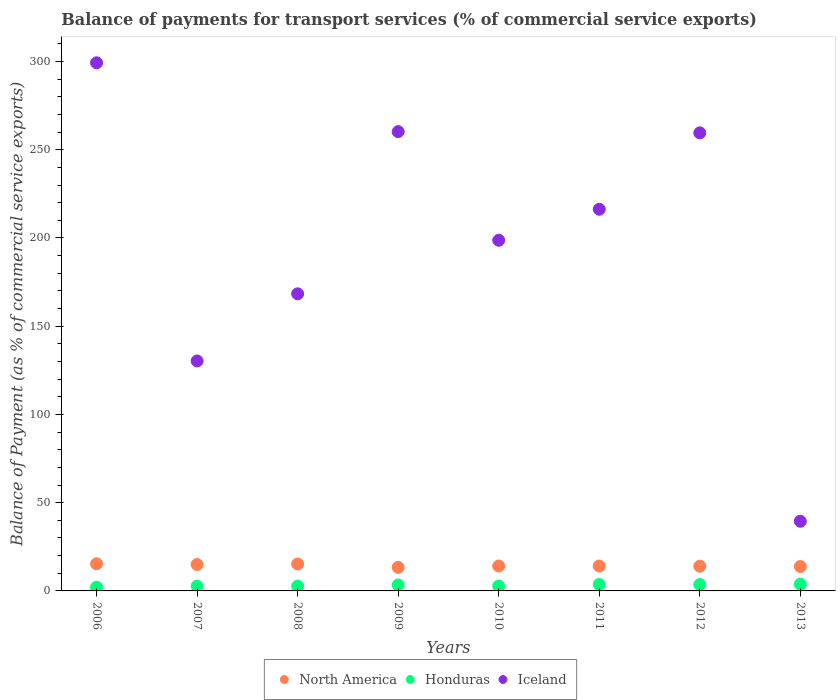What is the balance of payments for transport services in Honduras in 2010?
Offer a very short reply. 2.8. Across all years, what is the maximum balance of payments for transport services in Iceland?
Give a very brief answer. 299.28. Across all years, what is the minimum balance of payments for transport services in North America?
Give a very brief answer. 13.36. In which year was the balance of payments for transport services in North America maximum?
Offer a very short reply. 2006. In which year was the balance of payments for transport services in Iceland minimum?
Provide a succinct answer. 2013. What is the total balance of payments for transport services in Iceland in the graph?
Offer a terse response. 1572.26. What is the difference between the balance of payments for transport services in Honduras in 2010 and that in 2013?
Offer a very short reply. -1. What is the difference between the balance of payments for transport services in Honduras in 2011 and the balance of payments for transport services in North America in 2010?
Your answer should be very brief. -10.45. What is the average balance of payments for transport services in Honduras per year?
Your answer should be compact. 3.11. In the year 2011, what is the difference between the balance of payments for transport services in North America and balance of payments for transport services in Honduras?
Provide a succinct answer. 10.44. What is the ratio of the balance of payments for transport services in Honduras in 2010 to that in 2011?
Give a very brief answer. 0.77. What is the difference between the highest and the second highest balance of payments for transport services in North America?
Keep it short and to the point. 0.12. What is the difference between the highest and the lowest balance of payments for transport services in Iceland?
Offer a terse response. 259.8. Is the sum of the balance of payments for transport services in Iceland in 2006 and 2008 greater than the maximum balance of payments for transport services in Honduras across all years?
Offer a very short reply. Yes. Is it the case that in every year, the sum of the balance of payments for transport services in Iceland and balance of payments for transport services in North America  is greater than the balance of payments for transport services in Honduras?
Make the answer very short. Yes. Does the balance of payments for transport services in Honduras monotonically increase over the years?
Give a very brief answer. No. Is the balance of payments for transport services in Honduras strictly less than the balance of payments for transport services in North America over the years?
Ensure brevity in your answer.  Yes. How many dotlines are there?
Provide a short and direct response. 3. Are the values on the major ticks of Y-axis written in scientific E-notation?
Keep it short and to the point. No. Where does the legend appear in the graph?
Keep it short and to the point. Bottom center. What is the title of the graph?
Ensure brevity in your answer.  Balance of payments for transport services (% of commercial service exports). What is the label or title of the X-axis?
Ensure brevity in your answer.  Years. What is the label or title of the Y-axis?
Give a very brief answer. Balance of Payment (as % of commercial service exports). What is the Balance of Payment (as % of commercial service exports) in North America in 2006?
Keep it short and to the point. 15.37. What is the Balance of Payment (as % of commercial service exports) of Honduras in 2006?
Your response must be concise. 2.14. What is the Balance of Payment (as % of commercial service exports) in Iceland in 2006?
Your answer should be very brief. 299.28. What is the Balance of Payment (as % of commercial service exports) of North America in 2007?
Your answer should be compact. 14.97. What is the Balance of Payment (as % of commercial service exports) in Honduras in 2007?
Ensure brevity in your answer.  2.73. What is the Balance of Payment (as % of commercial service exports) in Iceland in 2007?
Your answer should be compact. 130.32. What is the Balance of Payment (as % of commercial service exports) of North America in 2008?
Ensure brevity in your answer.  15.25. What is the Balance of Payment (as % of commercial service exports) in Honduras in 2008?
Offer a very short reply. 2.75. What is the Balance of Payment (as % of commercial service exports) in Iceland in 2008?
Your answer should be very brief. 168.36. What is the Balance of Payment (as % of commercial service exports) in North America in 2009?
Ensure brevity in your answer.  13.36. What is the Balance of Payment (as % of commercial service exports) of Honduras in 2009?
Give a very brief answer. 3.39. What is the Balance of Payment (as % of commercial service exports) of Iceland in 2009?
Give a very brief answer. 260.27. What is the Balance of Payment (as % of commercial service exports) of North America in 2010?
Your answer should be very brief. 14.12. What is the Balance of Payment (as % of commercial service exports) of Honduras in 2010?
Keep it short and to the point. 2.8. What is the Balance of Payment (as % of commercial service exports) of Iceland in 2010?
Offer a very short reply. 198.71. What is the Balance of Payment (as % of commercial service exports) of North America in 2011?
Provide a succinct answer. 14.11. What is the Balance of Payment (as % of commercial service exports) in Honduras in 2011?
Make the answer very short. 3.66. What is the Balance of Payment (as % of commercial service exports) in Iceland in 2011?
Your answer should be very brief. 216.28. What is the Balance of Payment (as % of commercial service exports) of North America in 2012?
Keep it short and to the point. 13.99. What is the Balance of Payment (as % of commercial service exports) of Honduras in 2012?
Offer a terse response. 3.61. What is the Balance of Payment (as % of commercial service exports) of Iceland in 2012?
Provide a succinct answer. 259.57. What is the Balance of Payment (as % of commercial service exports) in North America in 2013?
Your response must be concise. 13.84. What is the Balance of Payment (as % of commercial service exports) in Honduras in 2013?
Keep it short and to the point. 3.8. What is the Balance of Payment (as % of commercial service exports) in Iceland in 2013?
Make the answer very short. 39.47. Across all years, what is the maximum Balance of Payment (as % of commercial service exports) in North America?
Give a very brief answer. 15.37. Across all years, what is the maximum Balance of Payment (as % of commercial service exports) of Honduras?
Provide a succinct answer. 3.8. Across all years, what is the maximum Balance of Payment (as % of commercial service exports) of Iceland?
Provide a succinct answer. 299.28. Across all years, what is the minimum Balance of Payment (as % of commercial service exports) of North America?
Ensure brevity in your answer.  13.36. Across all years, what is the minimum Balance of Payment (as % of commercial service exports) of Honduras?
Your answer should be compact. 2.14. Across all years, what is the minimum Balance of Payment (as % of commercial service exports) of Iceland?
Give a very brief answer. 39.47. What is the total Balance of Payment (as % of commercial service exports) of North America in the graph?
Offer a very short reply. 115.01. What is the total Balance of Payment (as % of commercial service exports) of Honduras in the graph?
Offer a very short reply. 24.88. What is the total Balance of Payment (as % of commercial service exports) in Iceland in the graph?
Your answer should be compact. 1572.26. What is the difference between the Balance of Payment (as % of commercial service exports) in North America in 2006 and that in 2007?
Provide a succinct answer. 0.4. What is the difference between the Balance of Payment (as % of commercial service exports) of Honduras in 2006 and that in 2007?
Ensure brevity in your answer.  -0.6. What is the difference between the Balance of Payment (as % of commercial service exports) of Iceland in 2006 and that in 2007?
Provide a short and direct response. 168.95. What is the difference between the Balance of Payment (as % of commercial service exports) in North America in 2006 and that in 2008?
Ensure brevity in your answer.  0.12. What is the difference between the Balance of Payment (as % of commercial service exports) in Honduras in 2006 and that in 2008?
Provide a succinct answer. -0.61. What is the difference between the Balance of Payment (as % of commercial service exports) of Iceland in 2006 and that in 2008?
Your answer should be very brief. 130.92. What is the difference between the Balance of Payment (as % of commercial service exports) of North America in 2006 and that in 2009?
Your response must be concise. 2.01. What is the difference between the Balance of Payment (as % of commercial service exports) of Honduras in 2006 and that in 2009?
Offer a terse response. -1.25. What is the difference between the Balance of Payment (as % of commercial service exports) in Iceland in 2006 and that in 2009?
Make the answer very short. 39.01. What is the difference between the Balance of Payment (as % of commercial service exports) of North America in 2006 and that in 2010?
Keep it short and to the point. 1.26. What is the difference between the Balance of Payment (as % of commercial service exports) in Honduras in 2006 and that in 2010?
Your answer should be very brief. -0.67. What is the difference between the Balance of Payment (as % of commercial service exports) of Iceland in 2006 and that in 2010?
Your answer should be compact. 100.57. What is the difference between the Balance of Payment (as % of commercial service exports) in North America in 2006 and that in 2011?
Your response must be concise. 1.27. What is the difference between the Balance of Payment (as % of commercial service exports) in Honduras in 2006 and that in 2011?
Offer a terse response. -1.53. What is the difference between the Balance of Payment (as % of commercial service exports) in Iceland in 2006 and that in 2011?
Give a very brief answer. 83. What is the difference between the Balance of Payment (as % of commercial service exports) of North America in 2006 and that in 2012?
Offer a terse response. 1.38. What is the difference between the Balance of Payment (as % of commercial service exports) in Honduras in 2006 and that in 2012?
Your answer should be compact. -1.47. What is the difference between the Balance of Payment (as % of commercial service exports) in Iceland in 2006 and that in 2012?
Offer a terse response. 39.71. What is the difference between the Balance of Payment (as % of commercial service exports) in North America in 2006 and that in 2013?
Your response must be concise. 1.53. What is the difference between the Balance of Payment (as % of commercial service exports) in Honduras in 2006 and that in 2013?
Make the answer very short. -1.67. What is the difference between the Balance of Payment (as % of commercial service exports) in Iceland in 2006 and that in 2013?
Make the answer very short. 259.8. What is the difference between the Balance of Payment (as % of commercial service exports) of North America in 2007 and that in 2008?
Provide a short and direct response. -0.28. What is the difference between the Balance of Payment (as % of commercial service exports) in Honduras in 2007 and that in 2008?
Ensure brevity in your answer.  -0.02. What is the difference between the Balance of Payment (as % of commercial service exports) in Iceland in 2007 and that in 2008?
Your answer should be very brief. -38.04. What is the difference between the Balance of Payment (as % of commercial service exports) in North America in 2007 and that in 2009?
Ensure brevity in your answer.  1.62. What is the difference between the Balance of Payment (as % of commercial service exports) of Honduras in 2007 and that in 2009?
Your response must be concise. -0.66. What is the difference between the Balance of Payment (as % of commercial service exports) of Iceland in 2007 and that in 2009?
Your response must be concise. -129.95. What is the difference between the Balance of Payment (as % of commercial service exports) of North America in 2007 and that in 2010?
Your answer should be very brief. 0.86. What is the difference between the Balance of Payment (as % of commercial service exports) in Honduras in 2007 and that in 2010?
Make the answer very short. -0.07. What is the difference between the Balance of Payment (as % of commercial service exports) in Iceland in 2007 and that in 2010?
Give a very brief answer. -68.38. What is the difference between the Balance of Payment (as % of commercial service exports) of North America in 2007 and that in 2011?
Provide a short and direct response. 0.87. What is the difference between the Balance of Payment (as % of commercial service exports) of Honduras in 2007 and that in 2011?
Offer a terse response. -0.93. What is the difference between the Balance of Payment (as % of commercial service exports) of Iceland in 2007 and that in 2011?
Give a very brief answer. -85.96. What is the difference between the Balance of Payment (as % of commercial service exports) of North America in 2007 and that in 2012?
Keep it short and to the point. 0.98. What is the difference between the Balance of Payment (as % of commercial service exports) in Honduras in 2007 and that in 2012?
Provide a succinct answer. -0.88. What is the difference between the Balance of Payment (as % of commercial service exports) of Iceland in 2007 and that in 2012?
Keep it short and to the point. -129.25. What is the difference between the Balance of Payment (as % of commercial service exports) in North America in 2007 and that in 2013?
Ensure brevity in your answer.  1.13. What is the difference between the Balance of Payment (as % of commercial service exports) in Honduras in 2007 and that in 2013?
Your answer should be very brief. -1.07. What is the difference between the Balance of Payment (as % of commercial service exports) of Iceland in 2007 and that in 2013?
Your answer should be compact. 90.85. What is the difference between the Balance of Payment (as % of commercial service exports) in North America in 2008 and that in 2009?
Provide a succinct answer. 1.89. What is the difference between the Balance of Payment (as % of commercial service exports) of Honduras in 2008 and that in 2009?
Provide a short and direct response. -0.64. What is the difference between the Balance of Payment (as % of commercial service exports) of Iceland in 2008 and that in 2009?
Give a very brief answer. -91.91. What is the difference between the Balance of Payment (as % of commercial service exports) in North America in 2008 and that in 2010?
Your response must be concise. 1.14. What is the difference between the Balance of Payment (as % of commercial service exports) in Honduras in 2008 and that in 2010?
Provide a succinct answer. -0.05. What is the difference between the Balance of Payment (as % of commercial service exports) in Iceland in 2008 and that in 2010?
Your answer should be compact. -30.35. What is the difference between the Balance of Payment (as % of commercial service exports) of North America in 2008 and that in 2011?
Your answer should be very brief. 1.15. What is the difference between the Balance of Payment (as % of commercial service exports) of Honduras in 2008 and that in 2011?
Offer a terse response. -0.91. What is the difference between the Balance of Payment (as % of commercial service exports) of Iceland in 2008 and that in 2011?
Your answer should be compact. -47.92. What is the difference between the Balance of Payment (as % of commercial service exports) of North America in 2008 and that in 2012?
Your response must be concise. 1.26. What is the difference between the Balance of Payment (as % of commercial service exports) of Honduras in 2008 and that in 2012?
Your answer should be very brief. -0.86. What is the difference between the Balance of Payment (as % of commercial service exports) in Iceland in 2008 and that in 2012?
Provide a short and direct response. -91.21. What is the difference between the Balance of Payment (as % of commercial service exports) in North America in 2008 and that in 2013?
Make the answer very short. 1.41. What is the difference between the Balance of Payment (as % of commercial service exports) of Honduras in 2008 and that in 2013?
Keep it short and to the point. -1.05. What is the difference between the Balance of Payment (as % of commercial service exports) of Iceland in 2008 and that in 2013?
Provide a short and direct response. 128.89. What is the difference between the Balance of Payment (as % of commercial service exports) in North America in 2009 and that in 2010?
Your response must be concise. -0.76. What is the difference between the Balance of Payment (as % of commercial service exports) in Honduras in 2009 and that in 2010?
Keep it short and to the point. 0.59. What is the difference between the Balance of Payment (as % of commercial service exports) in Iceland in 2009 and that in 2010?
Provide a succinct answer. 61.56. What is the difference between the Balance of Payment (as % of commercial service exports) of North America in 2009 and that in 2011?
Provide a succinct answer. -0.75. What is the difference between the Balance of Payment (as % of commercial service exports) of Honduras in 2009 and that in 2011?
Provide a succinct answer. -0.27. What is the difference between the Balance of Payment (as % of commercial service exports) in Iceland in 2009 and that in 2011?
Offer a very short reply. 43.99. What is the difference between the Balance of Payment (as % of commercial service exports) in North America in 2009 and that in 2012?
Offer a very short reply. -0.64. What is the difference between the Balance of Payment (as % of commercial service exports) of Honduras in 2009 and that in 2012?
Offer a very short reply. -0.22. What is the difference between the Balance of Payment (as % of commercial service exports) in Iceland in 2009 and that in 2012?
Ensure brevity in your answer.  0.7. What is the difference between the Balance of Payment (as % of commercial service exports) of North America in 2009 and that in 2013?
Your answer should be compact. -0.48. What is the difference between the Balance of Payment (as % of commercial service exports) in Honduras in 2009 and that in 2013?
Offer a terse response. -0.41. What is the difference between the Balance of Payment (as % of commercial service exports) of Iceland in 2009 and that in 2013?
Keep it short and to the point. 220.79. What is the difference between the Balance of Payment (as % of commercial service exports) of North America in 2010 and that in 2011?
Keep it short and to the point. 0.01. What is the difference between the Balance of Payment (as % of commercial service exports) of Honduras in 2010 and that in 2011?
Provide a succinct answer. -0.86. What is the difference between the Balance of Payment (as % of commercial service exports) in Iceland in 2010 and that in 2011?
Keep it short and to the point. -17.57. What is the difference between the Balance of Payment (as % of commercial service exports) in North America in 2010 and that in 2012?
Your answer should be compact. 0.12. What is the difference between the Balance of Payment (as % of commercial service exports) of Honduras in 2010 and that in 2012?
Keep it short and to the point. -0.81. What is the difference between the Balance of Payment (as % of commercial service exports) in Iceland in 2010 and that in 2012?
Your answer should be very brief. -60.86. What is the difference between the Balance of Payment (as % of commercial service exports) of North America in 2010 and that in 2013?
Provide a short and direct response. 0.27. What is the difference between the Balance of Payment (as % of commercial service exports) in Honduras in 2010 and that in 2013?
Your answer should be compact. -1. What is the difference between the Balance of Payment (as % of commercial service exports) in Iceland in 2010 and that in 2013?
Your answer should be compact. 159.23. What is the difference between the Balance of Payment (as % of commercial service exports) of North America in 2011 and that in 2012?
Make the answer very short. 0.11. What is the difference between the Balance of Payment (as % of commercial service exports) of Honduras in 2011 and that in 2012?
Offer a very short reply. 0.05. What is the difference between the Balance of Payment (as % of commercial service exports) in Iceland in 2011 and that in 2012?
Offer a terse response. -43.29. What is the difference between the Balance of Payment (as % of commercial service exports) in North America in 2011 and that in 2013?
Ensure brevity in your answer.  0.26. What is the difference between the Balance of Payment (as % of commercial service exports) of Honduras in 2011 and that in 2013?
Give a very brief answer. -0.14. What is the difference between the Balance of Payment (as % of commercial service exports) in Iceland in 2011 and that in 2013?
Offer a very short reply. 176.81. What is the difference between the Balance of Payment (as % of commercial service exports) in North America in 2012 and that in 2013?
Ensure brevity in your answer.  0.15. What is the difference between the Balance of Payment (as % of commercial service exports) of Honduras in 2012 and that in 2013?
Your response must be concise. -0.19. What is the difference between the Balance of Payment (as % of commercial service exports) in Iceland in 2012 and that in 2013?
Provide a succinct answer. 220.1. What is the difference between the Balance of Payment (as % of commercial service exports) in North America in 2006 and the Balance of Payment (as % of commercial service exports) in Honduras in 2007?
Your answer should be very brief. 12.64. What is the difference between the Balance of Payment (as % of commercial service exports) in North America in 2006 and the Balance of Payment (as % of commercial service exports) in Iceland in 2007?
Give a very brief answer. -114.95. What is the difference between the Balance of Payment (as % of commercial service exports) of Honduras in 2006 and the Balance of Payment (as % of commercial service exports) of Iceland in 2007?
Offer a very short reply. -128.19. What is the difference between the Balance of Payment (as % of commercial service exports) of North America in 2006 and the Balance of Payment (as % of commercial service exports) of Honduras in 2008?
Offer a terse response. 12.62. What is the difference between the Balance of Payment (as % of commercial service exports) in North America in 2006 and the Balance of Payment (as % of commercial service exports) in Iceland in 2008?
Your response must be concise. -152.99. What is the difference between the Balance of Payment (as % of commercial service exports) in Honduras in 2006 and the Balance of Payment (as % of commercial service exports) in Iceland in 2008?
Your answer should be compact. -166.23. What is the difference between the Balance of Payment (as % of commercial service exports) of North America in 2006 and the Balance of Payment (as % of commercial service exports) of Honduras in 2009?
Provide a short and direct response. 11.98. What is the difference between the Balance of Payment (as % of commercial service exports) in North America in 2006 and the Balance of Payment (as % of commercial service exports) in Iceland in 2009?
Offer a very short reply. -244.9. What is the difference between the Balance of Payment (as % of commercial service exports) in Honduras in 2006 and the Balance of Payment (as % of commercial service exports) in Iceland in 2009?
Your response must be concise. -258.13. What is the difference between the Balance of Payment (as % of commercial service exports) in North America in 2006 and the Balance of Payment (as % of commercial service exports) in Honduras in 2010?
Make the answer very short. 12.57. What is the difference between the Balance of Payment (as % of commercial service exports) of North America in 2006 and the Balance of Payment (as % of commercial service exports) of Iceland in 2010?
Your answer should be very brief. -183.34. What is the difference between the Balance of Payment (as % of commercial service exports) in Honduras in 2006 and the Balance of Payment (as % of commercial service exports) in Iceland in 2010?
Offer a very short reply. -196.57. What is the difference between the Balance of Payment (as % of commercial service exports) of North America in 2006 and the Balance of Payment (as % of commercial service exports) of Honduras in 2011?
Offer a terse response. 11.71. What is the difference between the Balance of Payment (as % of commercial service exports) of North America in 2006 and the Balance of Payment (as % of commercial service exports) of Iceland in 2011?
Give a very brief answer. -200.91. What is the difference between the Balance of Payment (as % of commercial service exports) of Honduras in 2006 and the Balance of Payment (as % of commercial service exports) of Iceland in 2011?
Your response must be concise. -214.15. What is the difference between the Balance of Payment (as % of commercial service exports) of North America in 2006 and the Balance of Payment (as % of commercial service exports) of Honduras in 2012?
Provide a succinct answer. 11.76. What is the difference between the Balance of Payment (as % of commercial service exports) in North America in 2006 and the Balance of Payment (as % of commercial service exports) in Iceland in 2012?
Your answer should be compact. -244.2. What is the difference between the Balance of Payment (as % of commercial service exports) in Honduras in 2006 and the Balance of Payment (as % of commercial service exports) in Iceland in 2012?
Your response must be concise. -257.44. What is the difference between the Balance of Payment (as % of commercial service exports) of North America in 2006 and the Balance of Payment (as % of commercial service exports) of Honduras in 2013?
Your answer should be very brief. 11.57. What is the difference between the Balance of Payment (as % of commercial service exports) in North America in 2006 and the Balance of Payment (as % of commercial service exports) in Iceland in 2013?
Your answer should be compact. -24.1. What is the difference between the Balance of Payment (as % of commercial service exports) of Honduras in 2006 and the Balance of Payment (as % of commercial service exports) of Iceland in 2013?
Provide a succinct answer. -37.34. What is the difference between the Balance of Payment (as % of commercial service exports) of North America in 2007 and the Balance of Payment (as % of commercial service exports) of Honduras in 2008?
Your answer should be very brief. 12.22. What is the difference between the Balance of Payment (as % of commercial service exports) of North America in 2007 and the Balance of Payment (as % of commercial service exports) of Iceland in 2008?
Provide a short and direct response. -153.39. What is the difference between the Balance of Payment (as % of commercial service exports) in Honduras in 2007 and the Balance of Payment (as % of commercial service exports) in Iceland in 2008?
Ensure brevity in your answer.  -165.63. What is the difference between the Balance of Payment (as % of commercial service exports) in North America in 2007 and the Balance of Payment (as % of commercial service exports) in Honduras in 2009?
Offer a very short reply. 11.58. What is the difference between the Balance of Payment (as % of commercial service exports) of North America in 2007 and the Balance of Payment (as % of commercial service exports) of Iceland in 2009?
Keep it short and to the point. -245.29. What is the difference between the Balance of Payment (as % of commercial service exports) of Honduras in 2007 and the Balance of Payment (as % of commercial service exports) of Iceland in 2009?
Ensure brevity in your answer.  -257.54. What is the difference between the Balance of Payment (as % of commercial service exports) in North America in 2007 and the Balance of Payment (as % of commercial service exports) in Honduras in 2010?
Your response must be concise. 12.17. What is the difference between the Balance of Payment (as % of commercial service exports) in North America in 2007 and the Balance of Payment (as % of commercial service exports) in Iceland in 2010?
Provide a short and direct response. -183.73. What is the difference between the Balance of Payment (as % of commercial service exports) of Honduras in 2007 and the Balance of Payment (as % of commercial service exports) of Iceland in 2010?
Offer a terse response. -195.98. What is the difference between the Balance of Payment (as % of commercial service exports) in North America in 2007 and the Balance of Payment (as % of commercial service exports) in Honduras in 2011?
Provide a short and direct response. 11.31. What is the difference between the Balance of Payment (as % of commercial service exports) in North America in 2007 and the Balance of Payment (as % of commercial service exports) in Iceland in 2011?
Your answer should be compact. -201.31. What is the difference between the Balance of Payment (as % of commercial service exports) in Honduras in 2007 and the Balance of Payment (as % of commercial service exports) in Iceland in 2011?
Give a very brief answer. -213.55. What is the difference between the Balance of Payment (as % of commercial service exports) in North America in 2007 and the Balance of Payment (as % of commercial service exports) in Honduras in 2012?
Your answer should be compact. 11.37. What is the difference between the Balance of Payment (as % of commercial service exports) in North America in 2007 and the Balance of Payment (as % of commercial service exports) in Iceland in 2012?
Offer a very short reply. -244.6. What is the difference between the Balance of Payment (as % of commercial service exports) of Honduras in 2007 and the Balance of Payment (as % of commercial service exports) of Iceland in 2012?
Provide a succinct answer. -256.84. What is the difference between the Balance of Payment (as % of commercial service exports) of North America in 2007 and the Balance of Payment (as % of commercial service exports) of Honduras in 2013?
Your answer should be compact. 11.17. What is the difference between the Balance of Payment (as % of commercial service exports) of North America in 2007 and the Balance of Payment (as % of commercial service exports) of Iceland in 2013?
Your answer should be compact. -24.5. What is the difference between the Balance of Payment (as % of commercial service exports) in Honduras in 2007 and the Balance of Payment (as % of commercial service exports) in Iceland in 2013?
Keep it short and to the point. -36.74. What is the difference between the Balance of Payment (as % of commercial service exports) in North America in 2008 and the Balance of Payment (as % of commercial service exports) in Honduras in 2009?
Your response must be concise. 11.86. What is the difference between the Balance of Payment (as % of commercial service exports) of North America in 2008 and the Balance of Payment (as % of commercial service exports) of Iceland in 2009?
Provide a succinct answer. -245.02. What is the difference between the Balance of Payment (as % of commercial service exports) in Honduras in 2008 and the Balance of Payment (as % of commercial service exports) in Iceland in 2009?
Provide a succinct answer. -257.52. What is the difference between the Balance of Payment (as % of commercial service exports) of North America in 2008 and the Balance of Payment (as % of commercial service exports) of Honduras in 2010?
Offer a terse response. 12.45. What is the difference between the Balance of Payment (as % of commercial service exports) of North America in 2008 and the Balance of Payment (as % of commercial service exports) of Iceland in 2010?
Provide a succinct answer. -183.46. What is the difference between the Balance of Payment (as % of commercial service exports) of Honduras in 2008 and the Balance of Payment (as % of commercial service exports) of Iceland in 2010?
Your answer should be compact. -195.96. What is the difference between the Balance of Payment (as % of commercial service exports) in North America in 2008 and the Balance of Payment (as % of commercial service exports) in Honduras in 2011?
Your answer should be very brief. 11.59. What is the difference between the Balance of Payment (as % of commercial service exports) of North America in 2008 and the Balance of Payment (as % of commercial service exports) of Iceland in 2011?
Offer a terse response. -201.03. What is the difference between the Balance of Payment (as % of commercial service exports) in Honduras in 2008 and the Balance of Payment (as % of commercial service exports) in Iceland in 2011?
Keep it short and to the point. -213.53. What is the difference between the Balance of Payment (as % of commercial service exports) in North America in 2008 and the Balance of Payment (as % of commercial service exports) in Honduras in 2012?
Your answer should be very brief. 11.64. What is the difference between the Balance of Payment (as % of commercial service exports) of North America in 2008 and the Balance of Payment (as % of commercial service exports) of Iceland in 2012?
Ensure brevity in your answer.  -244.32. What is the difference between the Balance of Payment (as % of commercial service exports) of Honduras in 2008 and the Balance of Payment (as % of commercial service exports) of Iceland in 2012?
Offer a terse response. -256.82. What is the difference between the Balance of Payment (as % of commercial service exports) of North America in 2008 and the Balance of Payment (as % of commercial service exports) of Honduras in 2013?
Make the answer very short. 11.45. What is the difference between the Balance of Payment (as % of commercial service exports) of North America in 2008 and the Balance of Payment (as % of commercial service exports) of Iceland in 2013?
Provide a short and direct response. -24.22. What is the difference between the Balance of Payment (as % of commercial service exports) of Honduras in 2008 and the Balance of Payment (as % of commercial service exports) of Iceland in 2013?
Ensure brevity in your answer.  -36.72. What is the difference between the Balance of Payment (as % of commercial service exports) of North America in 2009 and the Balance of Payment (as % of commercial service exports) of Honduras in 2010?
Offer a very short reply. 10.56. What is the difference between the Balance of Payment (as % of commercial service exports) of North America in 2009 and the Balance of Payment (as % of commercial service exports) of Iceland in 2010?
Keep it short and to the point. -185.35. What is the difference between the Balance of Payment (as % of commercial service exports) of Honduras in 2009 and the Balance of Payment (as % of commercial service exports) of Iceland in 2010?
Offer a very short reply. -195.32. What is the difference between the Balance of Payment (as % of commercial service exports) of North America in 2009 and the Balance of Payment (as % of commercial service exports) of Honduras in 2011?
Make the answer very short. 9.7. What is the difference between the Balance of Payment (as % of commercial service exports) in North America in 2009 and the Balance of Payment (as % of commercial service exports) in Iceland in 2011?
Offer a very short reply. -202.92. What is the difference between the Balance of Payment (as % of commercial service exports) of Honduras in 2009 and the Balance of Payment (as % of commercial service exports) of Iceland in 2011?
Your answer should be compact. -212.89. What is the difference between the Balance of Payment (as % of commercial service exports) of North America in 2009 and the Balance of Payment (as % of commercial service exports) of Honduras in 2012?
Your response must be concise. 9.75. What is the difference between the Balance of Payment (as % of commercial service exports) of North America in 2009 and the Balance of Payment (as % of commercial service exports) of Iceland in 2012?
Ensure brevity in your answer.  -246.21. What is the difference between the Balance of Payment (as % of commercial service exports) in Honduras in 2009 and the Balance of Payment (as % of commercial service exports) in Iceland in 2012?
Provide a short and direct response. -256.18. What is the difference between the Balance of Payment (as % of commercial service exports) in North America in 2009 and the Balance of Payment (as % of commercial service exports) in Honduras in 2013?
Ensure brevity in your answer.  9.56. What is the difference between the Balance of Payment (as % of commercial service exports) in North America in 2009 and the Balance of Payment (as % of commercial service exports) in Iceland in 2013?
Keep it short and to the point. -26.12. What is the difference between the Balance of Payment (as % of commercial service exports) in Honduras in 2009 and the Balance of Payment (as % of commercial service exports) in Iceland in 2013?
Provide a succinct answer. -36.08. What is the difference between the Balance of Payment (as % of commercial service exports) in North America in 2010 and the Balance of Payment (as % of commercial service exports) in Honduras in 2011?
Give a very brief answer. 10.45. What is the difference between the Balance of Payment (as % of commercial service exports) of North America in 2010 and the Balance of Payment (as % of commercial service exports) of Iceland in 2011?
Offer a terse response. -202.17. What is the difference between the Balance of Payment (as % of commercial service exports) in Honduras in 2010 and the Balance of Payment (as % of commercial service exports) in Iceland in 2011?
Ensure brevity in your answer.  -213.48. What is the difference between the Balance of Payment (as % of commercial service exports) of North America in 2010 and the Balance of Payment (as % of commercial service exports) of Honduras in 2012?
Offer a very short reply. 10.51. What is the difference between the Balance of Payment (as % of commercial service exports) in North America in 2010 and the Balance of Payment (as % of commercial service exports) in Iceland in 2012?
Your answer should be compact. -245.46. What is the difference between the Balance of Payment (as % of commercial service exports) in Honduras in 2010 and the Balance of Payment (as % of commercial service exports) in Iceland in 2012?
Your response must be concise. -256.77. What is the difference between the Balance of Payment (as % of commercial service exports) in North America in 2010 and the Balance of Payment (as % of commercial service exports) in Honduras in 2013?
Provide a short and direct response. 10.31. What is the difference between the Balance of Payment (as % of commercial service exports) of North America in 2010 and the Balance of Payment (as % of commercial service exports) of Iceland in 2013?
Ensure brevity in your answer.  -25.36. What is the difference between the Balance of Payment (as % of commercial service exports) in Honduras in 2010 and the Balance of Payment (as % of commercial service exports) in Iceland in 2013?
Offer a very short reply. -36.67. What is the difference between the Balance of Payment (as % of commercial service exports) in North America in 2011 and the Balance of Payment (as % of commercial service exports) in Honduras in 2012?
Your answer should be compact. 10.5. What is the difference between the Balance of Payment (as % of commercial service exports) of North America in 2011 and the Balance of Payment (as % of commercial service exports) of Iceland in 2012?
Make the answer very short. -245.47. What is the difference between the Balance of Payment (as % of commercial service exports) of Honduras in 2011 and the Balance of Payment (as % of commercial service exports) of Iceland in 2012?
Your answer should be compact. -255.91. What is the difference between the Balance of Payment (as % of commercial service exports) of North America in 2011 and the Balance of Payment (as % of commercial service exports) of Honduras in 2013?
Provide a short and direct response. 10.3. What is the difference between the Balance of Payment (as % of commercial service exports) in North America in 2011 and the Balance of Payment (as % of commercial service exports) in Iceland in 2013?
Provide a short and direct response. -25.37. What is the difference between the Balance of Payment (as % of commercial service exports) in Honduras in 2011 and the Balance of Payment (as % of commercial service exports) in Iceland in 2013?
Give a very brief answer. -35.81. What is the difference between the Balance of Payment (as % of commercial service exports) in North America in 2012 and the Balance of Payment (as % of commercial service exports) in Honduras in 2013?
Make the answer very short. 10.19. What is the difference between the Balance of Payment (as % of commercial service exports) in North America in 2012 and the Balance of Payment (as % of commercial service exports) in Iceland in 2013?
Ensure brevity in your answer.  -25.48. What is the difference between the Balance of Payment (as % of commercial service exports) in Honduras in 2012 and the Balance of Payment (as % of commercial service exports) in Iceland in 2013?
Your answer should be compact. -35.87. What is the average Balance of Payment (as % of commercial service exports) of North America per year?
Give a very brief answer. 14.38. What is the average Balance of Payment (as % of commercial service exports) of Honduras per year?
Provide a succinct answer. 3.11. What is the average Balance of Payment (as % of commercial service exports) of Iceland per year?
Offer a very short reply. 196.53. In the year 2006, what is the difference between the Balance of Payment (as % of commercial service exports) in North America and Balance of Payment (as % of commercial service exports) in Honduras?
Your response must be concise. 13.24. In the year 2006, what is the difference between the Balance of Payment (as % of commercial service exports) of North America and Balance of Payment (as % of commercial service exports) of Iceland?
Provide a short and direct response. -283.91. In the year 2006, what is the difference between the Balance of Payment (as % of commercial service exports) in Honduras and Balance of Payment (as % of commercial service exports) in Iceland?
Make the answer very short. -297.14. In the year 2007, what is the difference between the Balance of Payment (as % of commercial service exports) in North America and Balance of Payment (as % of commercial service exports) in Honduras?
Your response must be concise. 12.24. In the year 2007, what is the difference between the Balance of Payment (as % of commercial service exports) of North America and Balance of Payment (as % of commercial service exports) of Iceland?
Give a very brief answer. -115.35. In the year 2007, what is the difference between the Balance of Payment (as % of commercial service exports) in Honduras and Balance of Payment (as % of commercial service exports) in Iceland?
Offer a terse response. -127.59. In the year 2008, what is the difference between the Balance of Payment (as % of commercial service exports) of North America and Balance of Payment (as % of commercial service exports) of Honduras?
Make the answer very short. 12.5. In the year 2008, what is the difference between the Balance of Payment (as % of commercial service exports) in North America and Balance of Payment (as % of commercial service exports) in Iceland?
Provide a succinct answer. -153.11. In the year 2008, what is the difference between the Balance of Payment (as % of commercial service exports) in Honduras and Balance of Payment (as % of commercial service exports) in Iceland?
Offer a very short reply. -165.61. In the year 2009, what is the difference between the Balance of Payment (as % of commercial service exports) of North America and Balance of Payment (as % of commercial service exports) of Honduras?
Make the answer very short. 9.97. In the year 2009, what is the difference between the Balance of Payment (as % of commercial service exports) in North America and Balance of Payment (as % of commercial service exports) in Iceland?
Provide a succinct answer. -246.91. In the year 2009, what is the difference between the Balance of Payment (as % of commercial service exports) of Honduras and Balance of Payment (as % of commercial service exports) of Iceland?
Make the answer very short. -256.88. In the year 2010, what is the difference between the Balance of Payment (as % of commercial service exports) in North America and Balance of Payment (as % of commercial service exports) in Honduras?
Provide a short and direct response. 11.31. In the year 2010, what is the difference between the Balance of Payment (as % of commercial service exports) of North America and Balance of Payment (as % of commercial service exports) of Iceland?
Provide a short and direct response. -184.59. In the year 2010, what is the difference between the Balance of Payment (as % of commercial service exports) of Honduras and Balance of Payment (as % of commercial service exports) of Iceland?
Offer a very short reply. -195.91. In the year 2011, what is the difference between the Balance of Payment (as % of commercial service exports) in North America and Balance of Payment (as % of commercial service exports) in Honduras?
Offer a terse response. 10.44. In the year 2011, what is the difference between the Balance of Payment (as % of commercial service exports) in North America and Balance of Payment (as % of commercial service exports) in Iceland?
Offer a terse response. -202.18. In the year 2011, what is the difference between the Balance of Payment (as % of commercial service exports) of Honduras and Balance of Payment (as % of commercial service exports) of Iceland?
Your answer should be very brief. -212.62. In the year 2012, what is the difference between the Balance of Payment (as % of commercial service exports) of North America and Balance of Payment (as % of commercial service exports) of Honduras?
Make the answer very short. 10.39. In the year 2012, what is the difference between the Balance of Payment (as % of commercial service exports) in North America and Balance of Payment (as % of commercial service exports) in Iceland?
Your answer should be very brief. -245.58. In the year 2012, what is the difference between the Balance of Payment (as % of commercial service exports) in Honduras and Balance of Payment (as % of commercial service exports) in Iceland?
Keep it short and to the point. -255.96. In the year 2013, what is the difference between the Balance of Payment (as % of commercial service exports) in North America and Balance of Payment (as % of commercial service exports) in Honduras?
Make the answer very short. 10.04. In the year 2013, what is the difference between the Balance of Payment (as % of commercial service exports) of North America and Balance of Payment (as % of commercial service exports) of Iceland?
Provide a succinct answer. -25.63. In the year 2013, what is the difference between the Balance of Payment (as % of commercial service exports) in Honduras and Balance of Payment (as % of commercial service exports) in Iceland?
Provide a short and direct response. -35.67. What is the ratio of the Balance of Payment (as % of commercial service exports) of North America in 2006 to that in 2007?
Keep it short and to the point. 1.03. What is the ratio of the Balance of Payment (as % of commercial service exports) in Honduras in 2006 to that in 2007?
Offer a terse response. 0.78. What is the ratio of the Balance of Payment (as % of commercial service exports) in Iceland in 2006 to that in 2007?
Provide a short and direct response. 2.3. What is the ratio of the Balance of Payment (as % of commercial service exports) of Honduras in 2006 to that in 2008?
Your response must be concise. 0.78. What is the ratio of the Balance of Payment (as % of commercial service exports) in Iceland in 2006 to that in 2008?
Your answer should be very brief. 1.78. What is the ratio of the Balance of Payment (as % of commercial service exports) of North America in 2006 to that in 2009?
Ensure brevity in your answer.  1.15. What is the ratio of the Balance of Payment (as % of commercial service exports) of Honduras in 2006 to that in 2009?
Offer a very short reply. 0.63. What is the ratio of the Balance of Payment (as % of commercial service exports) of Iceland in 2006 to that in 2009?
Provide a short and direct response. 1.15. What is the ratio of the Balance of Payment (as % of commercial service exports) of North America in 2006 to that in 2010?
Make the answer very short. 1.09. What is the ratio of the Balance of Payment (as % of commercial service exports) of Honduras in 2006 to that in 2010?
Provide a succinct answer. 0.76. What is the ratio of the Balance of Payment (as % of commercial service exports) in Iceland in 2006 to that in 2010?
Offer a terse response. 1.51. What is the ratio of the Balance of Payment (as % of commercial service exports) of North America in 2006 to that in 2011?
Ensure brevity in your answer.  1.09. What is the ratio of the Balance of Payment (as % of commercial service exports) in Honduras in 2006 to that in 2011?
Your answer should be very brief. 0.58. What is the ratio of the Balance of Payment (as % of commercial service exports) of Iceland in 2006 to that in 2011?
Ensure brevity in your answer.  1.38. What is the ratio of the Balance of Payment (as % of commercial service exports) of North America in 2006 to that in 2012?
Provide a succinct answer. 1.1. What is the ratio of the Balance of Payment (as % of commercial service exports) of Honduras in 2006 to that in 2012?
Offer a terse response. 0.59. What is the ratio of the Balance of Payment (as % of commercial service exports) in Iceland in 2006 to that in 2012?
Offer a terse response. 1.15. What is the ratio of the Balance of Payment (as % of commercial service exports) of North America in 2006 to that in 2013?
Your answer should be compact. 1.11. What is the ratio of the Balance of Payment (as % of commercial service exports) in Honduras in 2006 to that in 2013?
Your answer should be compact. 0.56. What is the ratio of the Balance of Payment (as % of commercial service exports) in Iceland in 2006 to that in 2013?
Your answer should be compact. 7.58. What is the ratio of the Balance of Payment (as % of commercial service exports) of North America in 2007 to that in 2008?
Make the answer very short. 0.98. What is the ratio of the Balance of Payment (as % of commercial service exports) in Iceland in 2007 to that in 2008?
Offer a very short reply. 0.77. What is the ratio of the Balance of Payment (as % of commercial service exports) in North America in 2007 to that in 2009?
Give a very brief answer. 1.12. What is the ratio of the Balance of Payment (as % of commercial service exports) in Honduras in 2007 to that in 2009?
Your answer should be compact. 0.81. What is the ratio of the Balance of Payment (as % of commercial service exports) of Iceland in 2007 to that in 2009?
Provide a short and direct response. 0.5. What is the ratio of the Balance of Payment (as % of commercial service exports) in North America in 2007 to that in 2010?
Give a very brief answer. 1.06. What is the ratio of the Balance of Payment (as % of commercial service exports) in Honduras in 2007 to that in 2010?
Make the answer very short. 0.98. What is the ratio of the Balance of Payment (as % of commercial service exports) in Iceland in 2007 to that in 2010?
Offer a very short reply. 0.66. What is the ratio of the Balance of Payment (as % of commercial service exports) of North America in 2007 to that in 2011?
Your answer should be very brief. 1.06. What is the ratio of the Balance of Payment (as % of commercial service exports) of Honduras in 2007 to that in 2011?
Provide a succinct answer. 0.75. What is the ratio of the Balance of Payment (as % of commercial service exports) in Iceland in 2007 to that in 2011?
Make the answer very short. 0.6. What is the ratio of the Balance of Payment (as % of commercial service exports) in North America in 2007 to that in 2012?
Provide a succinct answer. 1.07. What is the ratio of the Balance of Payment (as % of commercial service exports) in Honduras in 2007 to that in 2012?
Provide a short and direct response. 0.76. What is the ratio of the Balance of Payment (as % of commercial service exports) in Iceland in 2007 to that in 2012?
Offer a terse response. 0.5. What is the ratio of the Balance of Payment (as % of commercial service exports) of North America in 2007 to that in 2013?
Keep it short and to the point. 1.08. What is the ratio of the Balance of Payment (as % of commercial service exports) of Honduras in 2007 to that in 2013?
Give a very brief answer. 0.72. What is the ratio of the Balance of Payment (as % of commercial service exports) in Iceland in 2007 to that in 2013?
Give a very brief answer. 3.3. What is the ratio of the Balance of Payment (as % of commercial service exports) of North America in 2008 to that in 2009?
Offer a terse response. 1.14. What is the ratio of the Balance of Payment (as % of commercial service exports) of Honduras in 2008 to that in 2009?
Provide a succinct answer. 0.81. What is the ratio of the Balance of Payment (as % of commercial service exports) of Iceland in 2008 to that in 2009?
Your answer should be very brief. 0.65. What is the ratio of the Balance of Payment (as % of commercial service exports) of North America in 2008 to that in 2010?
Offer a very short reply. 1.08. What is the ratio of the Balance of Payment (as % of commercial service exports) of Honduras in 2008 to that in 2010?
Your answer should be compact. 0.98. What is the ratio of the Balance of Payment (as % of commercial service exports) in Iceland in 2008 to that in 2010?
Give a very brief answer. 0.85. What is the ratio of the Balance of Payment (as % of commercial service exports) in North America in 2008 to that in 2011?
Offer a very short reply. 1.08. What is the ratio of the Balance of Payment (as % of commercial service exports) of Honduras in 2008 to that in 2011?
Make the answer very short. 0.75. What is the ratio of the Balance of Payment (as % of commercial service exports) in Iceland in 2008 to that in 2011?
Give a very brief answer. 0.78. What is the ratio of the Balance of Payment (as % of commercial service exports) in North America in 2008 to that in 2012?
Your answer should be very brief. 1.09. What is the ratio of the Balance of Payment (as % of commercial service exports) in Honduras in 2008 to that in 2012?
Your answer should be very brief. 0.76. What is the ratio of the Balance of Payment (as % of commercial service exports) of Iceland in 2008 to that in 2012?
Provide a succinct answer. 0.65. What is the ratio of the Balance of Payment (as % of commercial service exports) in North America in 2008 to that in 2013?
Give a very brief answer. 1.1. What is the ratio of the Balance of Payment (as % of commercial service exports) in Honduras in 2008 to that in 2013?
Give a very brief answer. 0.72. What is the ratio of the Balance of Payment (as % of commercial service exports) in Iceland in 2008 to that in 2013?
Offer a very short reply. 4.27. What is the ratio of the Balance of Payment (as % of commercial service exports) in North America in 2009 to that in 2010?
Give a very brief answer. 0.95. What is the ratio of the Balance of Payment (as % of commercial service exports) in Honduras in 2009 to that in 2010?
Your answer should be compact. 1.21. What is the ratio of the Balance of Payment (as % of commercial service exports) of Iceland in 2009 to that in 2010?
Your answer should be very brief. 1.31. What is the ratio of the Balance of Payment (as % of commercial service exports) in North America in 2009 to that in 2011?
Offer a terse response. 0.95. What is the ratio of the Balance of Payment (as % of commercial service exports) in Honduras in 2009 to that in 2011?
Offer a terse response. 0.93. What is the ratio of the Balance of Payment (as % of commercial service exports) in Iceland in 2009 to that in 2011?
Keep it short and to the point. 1.2. What is the ratio of the Balance of Payment (as % of commercial service exports) of North America in 2009 to that in 2012?
Your answer should be compact. 0.95. What is the ratio of the Balance of Payment (as % of commercial service exports) in Honduras in 2009 to that in 2012?
Provide a succinct answer. 0.94. What is the ratio of the Balance of Payment (as % of commercial service exports) of Honduras in 2009 to that in 2013?
Give a very brief answer. 0.89. What is the ratio of the Balance of Payment (as % of commercial service exports) of Iceland in 2009 to that in 2013?
Your answer should be compact. 6.59. What is the ratio of the Balance of Payment (as % of commercial service exports) in North America in 2010 to that in 2011?
Provide a short and direct response. 1. What is the ratio of the Balance of Payment (as % of commercial service exports) in Honduras in 2010 to that in 2011?
Provide a short and direct response. 0.77. What is the ratio of the Balance of Payment (as % of commercial service exports) of Iceland in 2010 to that in 2011?
Offer a very short reply. 0.92. What is the ratio of the Balance of Payment (as % of commercial service exports) of North America in 2010 to that in 2012?
Ensure brevity in your answer.  1.01. What is the ratio of the Balance of Payment (as % of commercial service exports) in Honduras in 2010 to that in 2012?
Make the answer very short. 0.78. What is the ratio of the Balance of Payment (as % of commercial service exports) in Iceland in 2010 to that in 2012?
Your answer should be compact. 0.77. What is the ratio of the Balance of Payment (as % of commercial service exports) of North America in 2010 to that in 2013?
Your response must be concise. 1.02. What is the ratio of the Balance of Payment (as % of commercial service exports) of Honduras in 2010 to that in 2013?
Make the answer very short. 0.74. What is the ratio of the Balance of Payment (as % of commercial service exports) of Iceland in 2010 to that in 2013?
Your answer should be very brief. 5.03. What is the ratio of the Balance of Payment (as % of commercial service exports) of North America in 2011 to that in 2012?
Keep it short and to the point. 1.01. What is the ratio of the Balance of Payment (as % of commercial service exports) in Honduras in 2011 to that in 2012?
Provide a short and direct response. 1.01. What is the ratio of the Balance of Payment (as % of commercial service exports) of Iceland in 2011 to that in 2012?
Provide a succinct answer. 0.83. What is the ratio of the Balance of Payment (as % of commercial service exports) in North America in 2011 to that in 2013?
Keep it short and to the point. 1.02. What is the ratio of the Balance of Payment (as % of commercial service exports) of Iceland in 2011 to that in 2013?
Provide a succinct answer. 5.48. What is the ratio of the Balance of Payment (as % of commercial service exports) of North America in 2012 to that in 2013?
Give a very brief answer. 1.01. What is the ratio of the Balance of Payment (as % of commercial service exports) of Honduras in 2012 to that in 2013?
Your answer should be very brief. 0.95. What is the ratio of the Balance of Payment (as % of commercial service exports) of Iceland in 2012 to that in 2013?
Make the answer very short. 6.58. What is the difference between the highest and the second highest Balance of Payment (as % of commercial service exports) in North America?
Provide a succinct answer. 0.12. What is the difference between the highest and the second highest Balance of Payment (as % of commercial service exports) in Honduras?
Provide a short and direct response. 0.14. What is the difference between the highest and the second highest Balance of Payment (as % of commercial service exports) of Iceland?
Your answer should be compact. 39.01. What is the difference between the highest and the lowest Balance of Payment (as % of commercial service exports) of North America?
Your response must be concise. 2.01. What is the difference between the highest and the lowest Balance of Payment (as % of commercial service exports) of Honduras?
Make the answer very short. 1.67. What is the difference between the highest and the lowest Balance of Payment (as % of commercial service exports) in Iceland?
Your response must be concise. 259.8. 